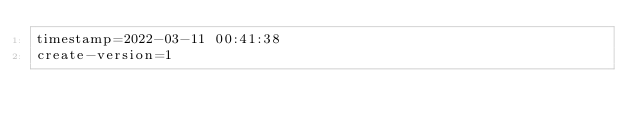Convert code to text. <code><loc_0><loc_0><loc_500><loc_500><_VisualBasic_>timestamp=2022-03-11 00:41:38
create-version=1</code> 